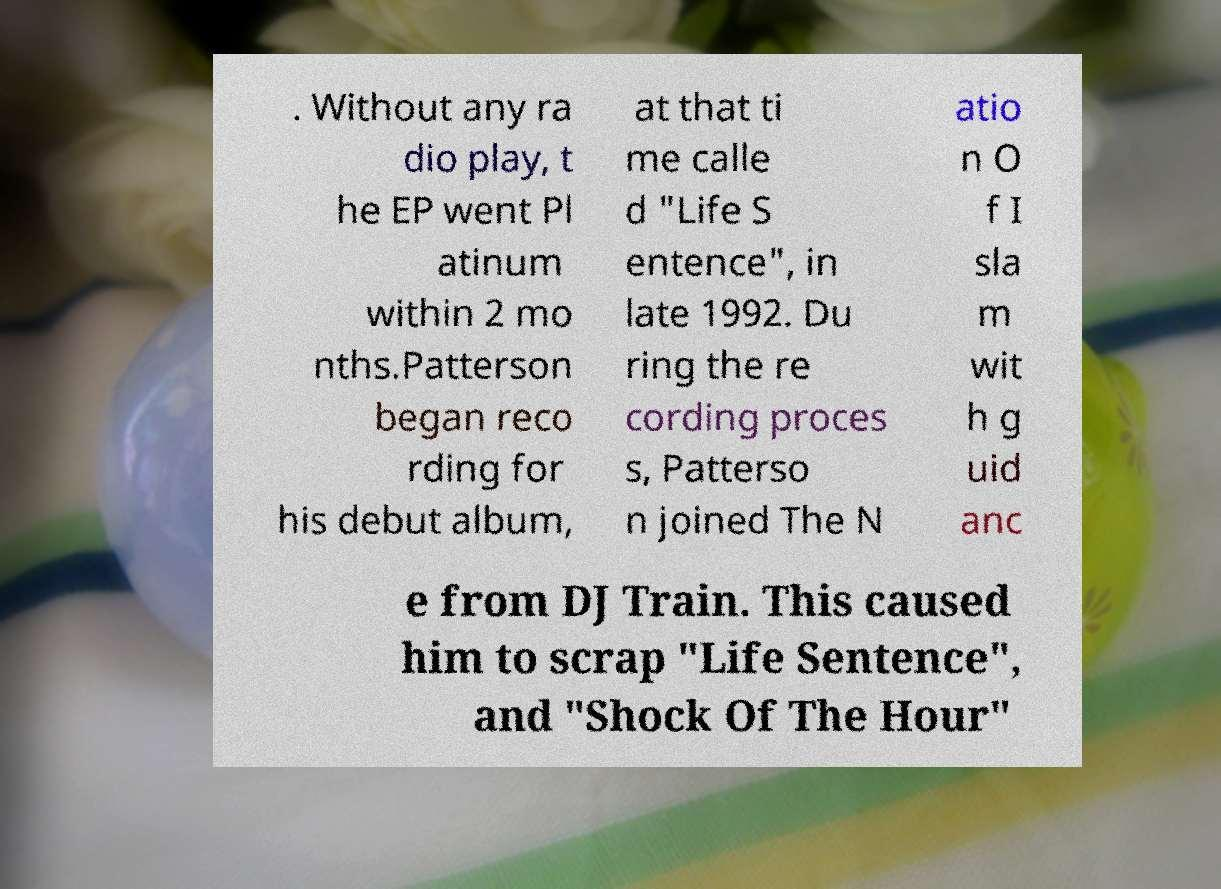There's text embedded in this image that I need extracted. Can you transcribe it verbatim? . Without any ra dio play, t he EP went Pl atinum within 2 mo nths.Patterson began reco rding for his debut album, at that ti me calle d "Life S entence", in late 1992. Du ring the re cording proces s, Patterso n joined The N atio n O f I sla m wit h g uid anc e from DJ Train. This caused him to scrap "Life Sentence", and "Shock Of The Hour" 